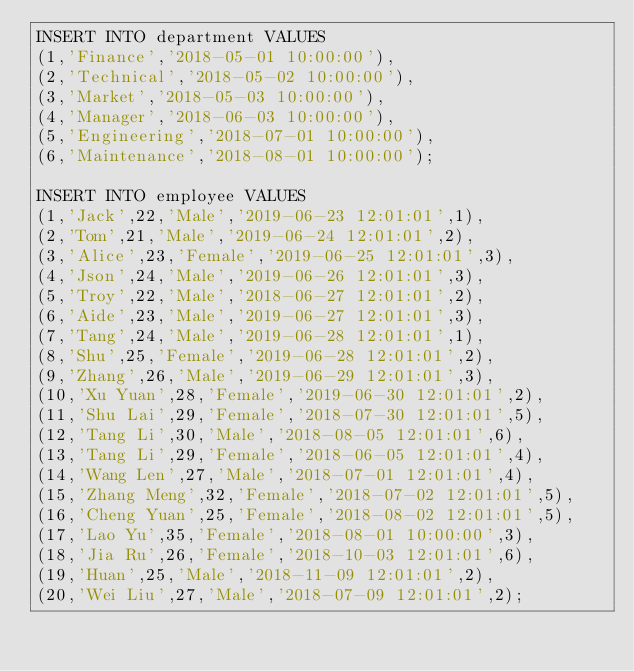<code> <loc_0><loc_0><loc_500><loc_500><_SQL_>INSERT INTO department VALUES
(1,'Finance','2018-05-01 10:00:00'),
(2,'Technical','2018-05-02 10:00:00'),
(3,'Market','2018-05-03 10:00:00'),
(4,'Manager','2018-06-03 10:00:00'),
(5,'Engineering','2018-07-01 10:00:00'),
(6,'Maintenance','2018-08-01 10:00:00');

INSERT INTO employee VALUES
(1,'Jack',22,'Male','2019-06-23 12:01:01',1),
(2,'Tom',21,'Male','2019-06-24 12:01:01',2),
(3,'Alice',23,'Female','2019-06-25 12:01:01',3),
(4,'Json',24,'Male','2019-06-26 12:01:01',3),
(5,'Troy',22,'Male','2018-06-27 12:01:01',2),
(6,'Aide',23,'Male','2019-06-27 12:01:01',3),
(7,'Tang',24,'Male','2019-06-28 12:01:01',1),
(8,'Shu',25,'Female','2019-06-28 12:01:01',2),
(9,'Zhang',26,'Male','2019-06-29 12:01:01',3),
(10,'Xu Yuan',28,'Female','2019-06-30 12:01:01',2),
(11,'Shu Lai',29,'Female','2018-07-30 12:01:01',5),
(12,'Tang Li',30,'Male','2018-08-05 12:01:01',6),
(13,'Tang Li',29,'Female','2018-06-05 12:01:01',4),
(14,'Wang Len',27,'Male','2018-07-01 12:01:01',4),
(15,'Zhang Meng',32,'Female','2018-07-02 12:01:01',5),
(16,'Cheng Yuan',25,'Female','2018-08-02 12:01:01',5),
(17,'Lao Yu',35,'Female','2018-08-01 10:00:00',3),
(18,'Jia Ru',26,'Female','2018-10-03 12:01:01',6),
(19,'Huan',25,'Male','2018-11-09 12:01:01',2),
(20,'Wei Liu',27,'Male','2018-07-09 12:01:01',2);
</code> 